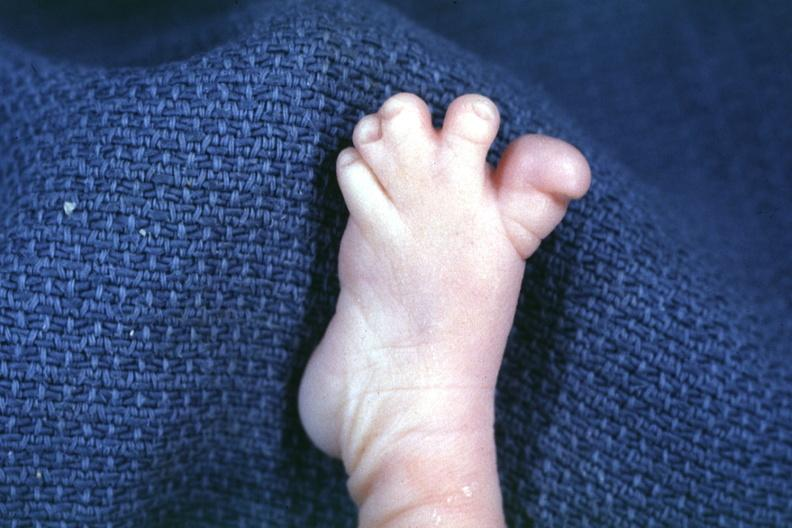s foot present?
Answer the question using a single word or phrase. Yes 